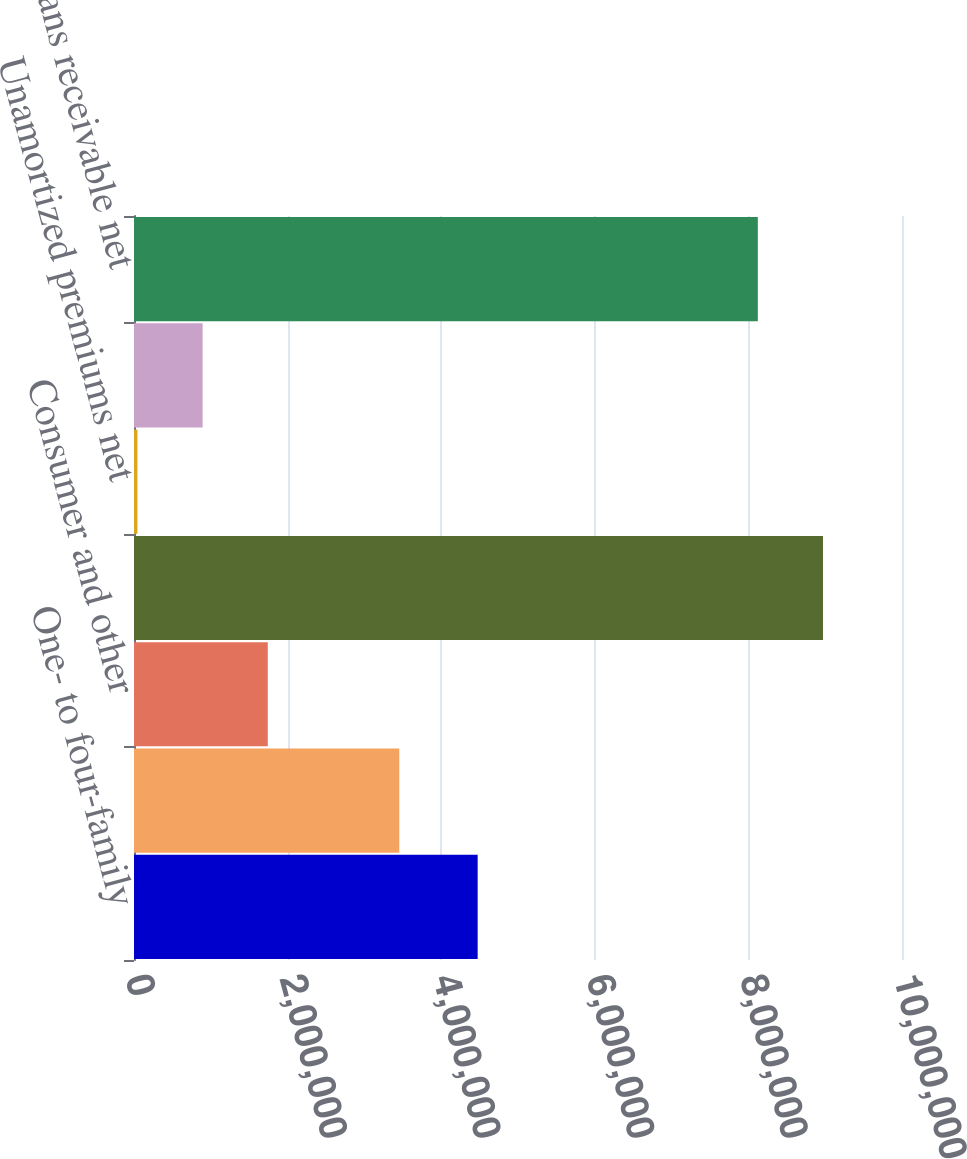Convert chart to OTSL. <chart><loc_0><loc_0><loc_500><loc_500><bar_chart><fcel>One- to four-family<fcel>Home equity<fcel>Consumer and other<fcel>Total loans receivable<fcel>Unamortized premiums net<fcel>Allowance for loan losses<fcel>Total loans receivable net<nl><fcel>4.47479e+06<fcel>3.45396e+06<fcel>1.74194e+06<fcel>8.97123e+06<fcel>44713<fcel>893328<fcel>8.12262e+06<nl></chart> 